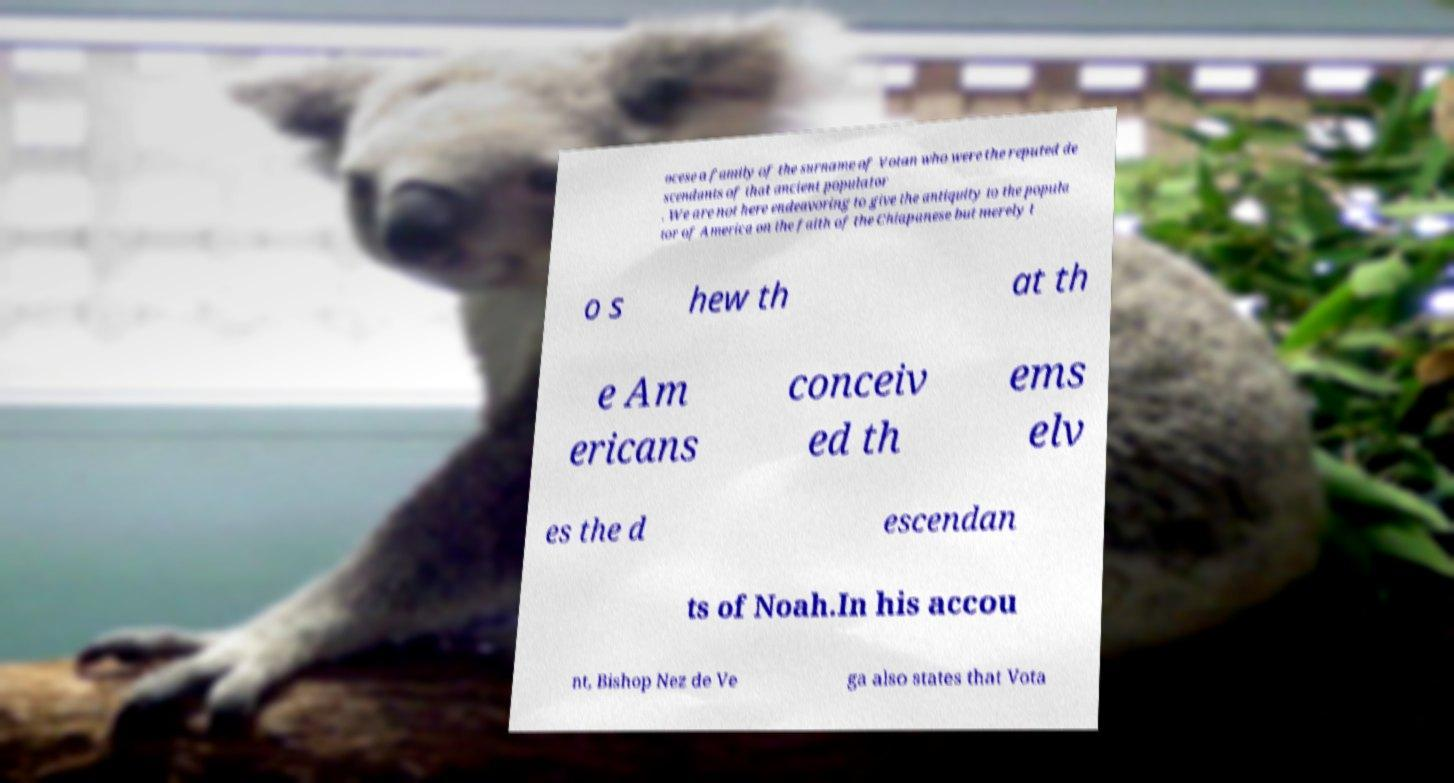Could you extract and type out the text from this image? ocese a family of the surname of Votan who were the reputed de scendants of that ancient populator . We are not here endeavoring to give the antiquity to the popula tor of America on the faith of the Chiapanese but merely t o s hew th at th e Am ericans conceiv ed th ems elv es the d escendan ts of Noah.In his accou nt, Bishop Nez de Ve ga also states that Vota 